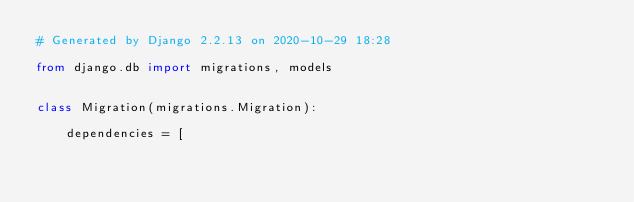Convert code to text. <code><loc_0><loc_0><loc_500><loc_500><_Python_># Generated by Django 2.2.13 on 2020-10-29 18:28

from django.db import migrations, models


class Migration(migrations.Migration):

    dependencies = [</code> 